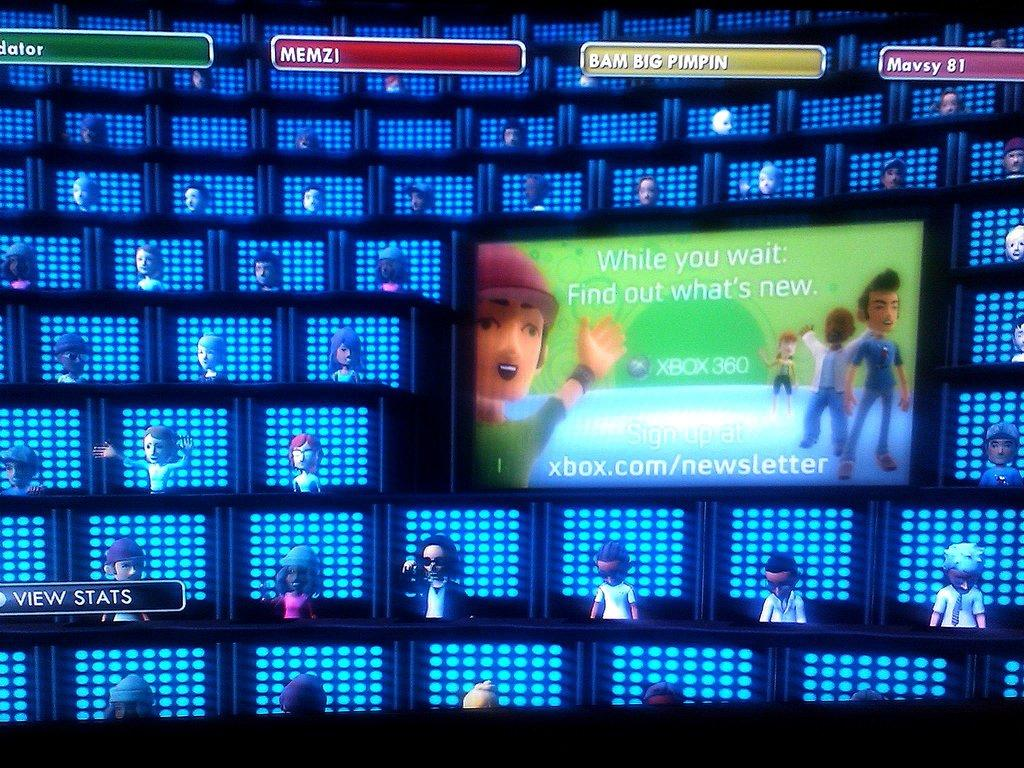<image>
Give a short and clear explanation of the subsequent image. Memzi, Bam Big Pimpin, and Mavsy 81 are three of the Xbox competitors. 